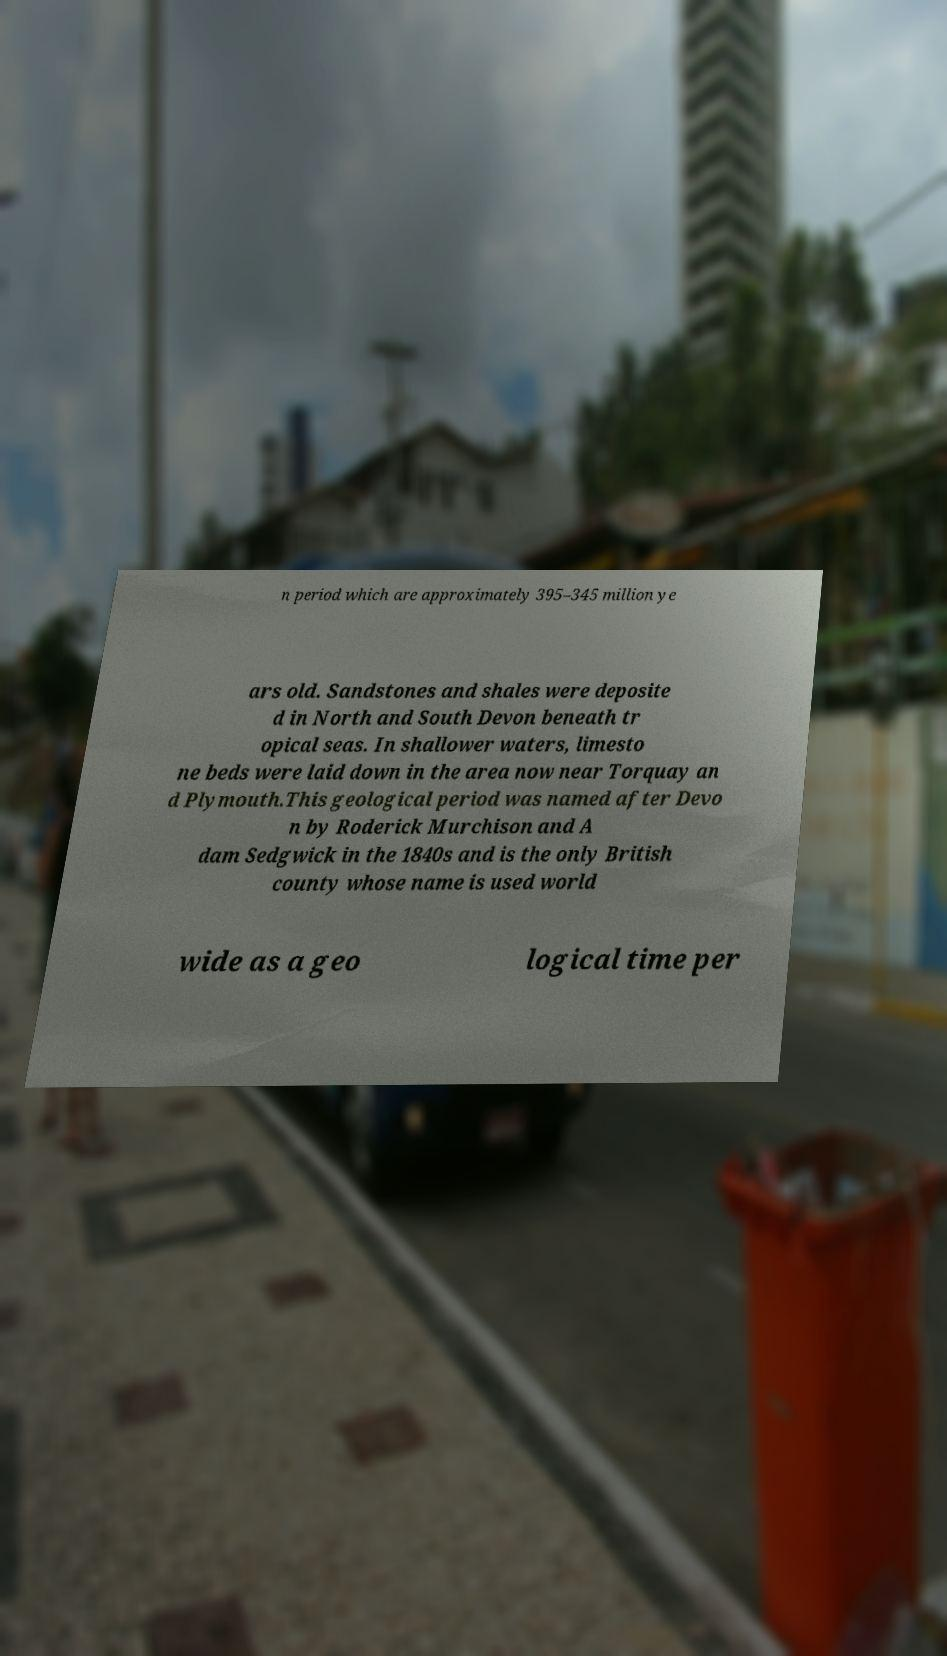Could you assist in decoding the text presented in this image and type it out clearly? n period which are approximately 395–345 million ye ars old. Sandstones and shales were deposite d in North and South Devon beneath tr opical seas. In shallower waters, limesto ne beds were laid down in the area now near Torquay an d Plymouth.This geological period was named after Devo n by Roderick Murchison and A dam Sedgwick in the 1840s and is the only British county whose name is used world wide as a geo logical time per 